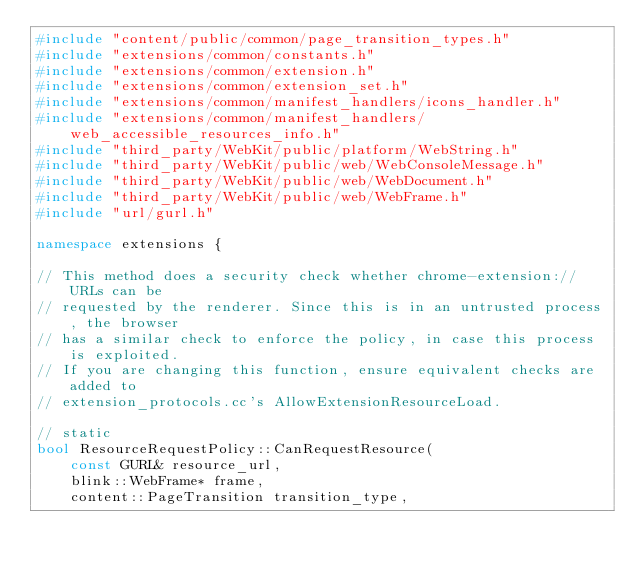<code> <loc_0><loc_0><loc_500><loc_500><_C++_>#include "content/public/common/page_transition_types.h"
#include "extensions/common/constants.h"
#include "extensions/common/extension.h"
#include "extensions/common/extension_set.h"
#include "extensions/common/manifest_handlers/icons_handler.h"
#include "extensions/common/manifest_handlers/web_accessible_resources_info.h"
#include "third_party/WebKit/public/platform/WebString.h"
#include "third_party/WebKit/public/web/WebConsoleMessage.h"
#include "third_party/WebKit/public/web/WebDocument.h"
#include "third_party/WebKit/public/web/WebFrame.h"
#include "url/gurl.h"

namespace extensions {

// This method does a security check whether chrome-extension:// URLs can be
// requested by the renderer. Since this is in an untrusted process, the browser
// has a similar check to enforce the policy, in case this process is exploited.
// If you are changing this function, ensure equivalent checks are added to
// extension_protocols.cc's AllowExtensionResourceLoad.

// static
bool ResourceRequestPolicy::CanRequestResource(
    const GURL& resource_url,
    blink::WebFrame* frame,
    content::PageTransition transition_type,</code> 